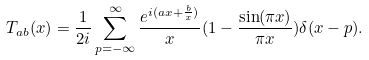<formula> <loc_0><loc_0><loc_500><loc_500>T _ { a b } ( x ) = \frac { 1 } { 2 i } \sum _ { p = - \infty } ^ { \infty } \frac { e ^ { i ( a x + \frac { b } { x } ) } } x ( 1 - \frac { \sin ( \pi x ) } { \pi x } ) \delta ( x - p ) .</formula> 